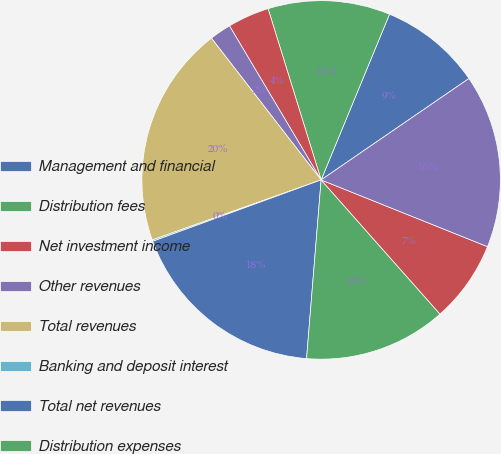Convert chart to OTSL. <chart><loc_0><loc_0><loc_500><loc_500><pie_chart><fcel>Management and financial<fcel>Distribution fees<fcel>Net investment income<fcel>Other revenues<fcel>Total revenues<fcel>Banking and deposit interest<fcel>Total net revenues<fcel>Distribution expenses<fcel>General and administrative<fcel>Total expenses<nl><fcel>9.2%<fcel>11.01%<fcel>3.76%<fcel>1.94%<fcel>19.95%<fcel>0.13%<fcel>18.14%<fcel>12.83%<fcel>7.39%<fcel>15.64%<nl></chart> 